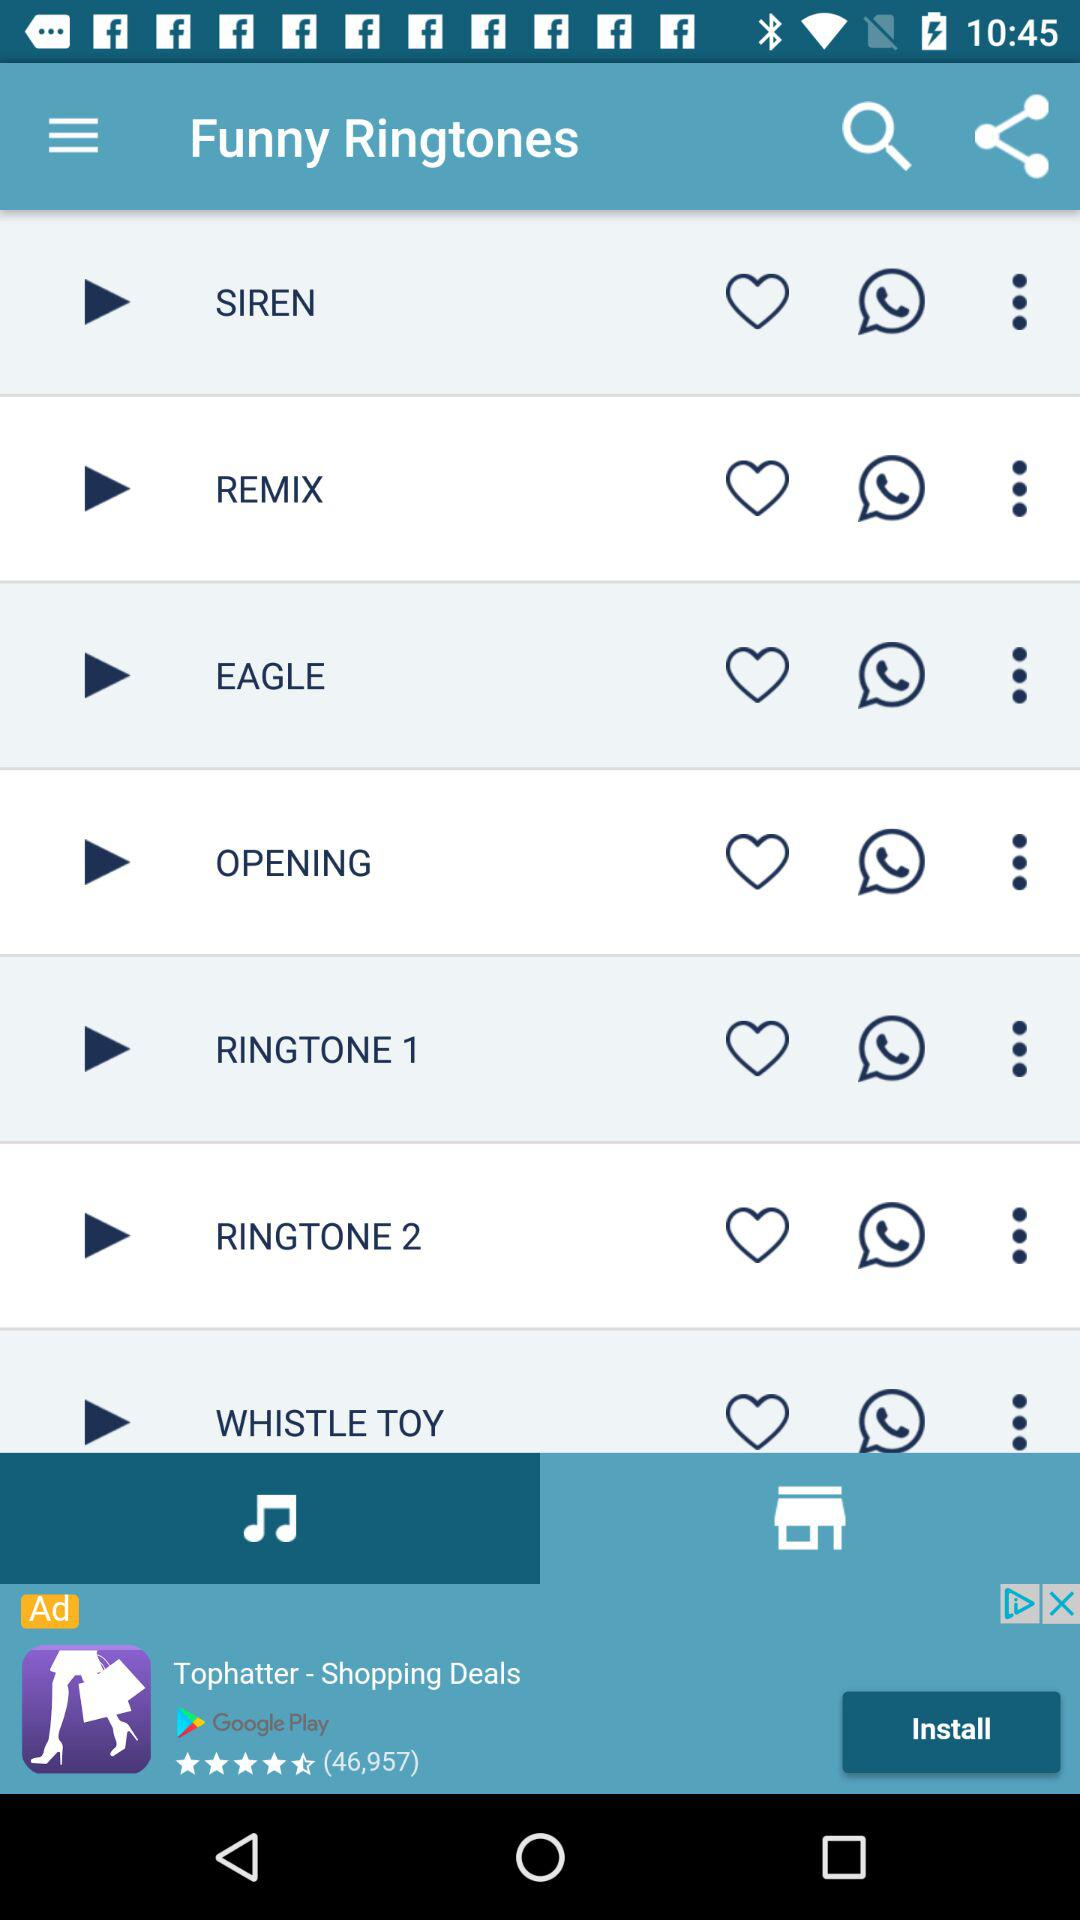Which tab is currently selected? The currently selected tab is "Music". 